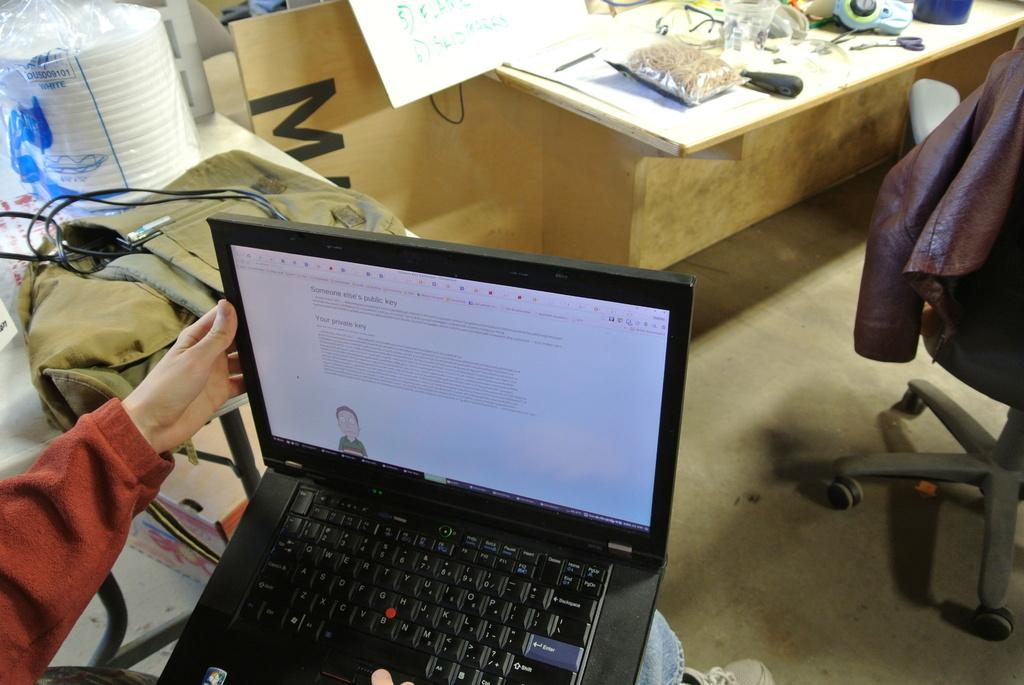What electronic device can be seen in the image? There is a laptop in the image. What part of a person is visible in the image? A human hand is visible in the image. What type of object is present in the background of the image? There is a food item in the background of the image. What is covered on the table in the image? There is a cover on a table in the image. What type of furniture is present in the image? There is a chair in the image. What type of club is the person joining in the image? There is no club or indication of joining a club present in the image. What word is being spelled out by the food item in the background? There is no word being spelled out by the food item in the background; it is simply a food item. 